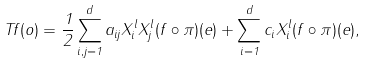Convert formula to latex. <formula><loc_0><loc_0><loc_500><loc_500>T f ( o ) = \frac { 1 } { 2 } \sum _ { i , j = 1 } ^ { d } a _ { i j } X _ { i } ^ { l } X _ { j } ^ { l } ( f \circ \pi ) ( e ) + \sum _ { i = 1 } ^ { d } c _ { i } X _ { i } ^ { l } ( f \circ \pi ) ( e ) ,</formula> 